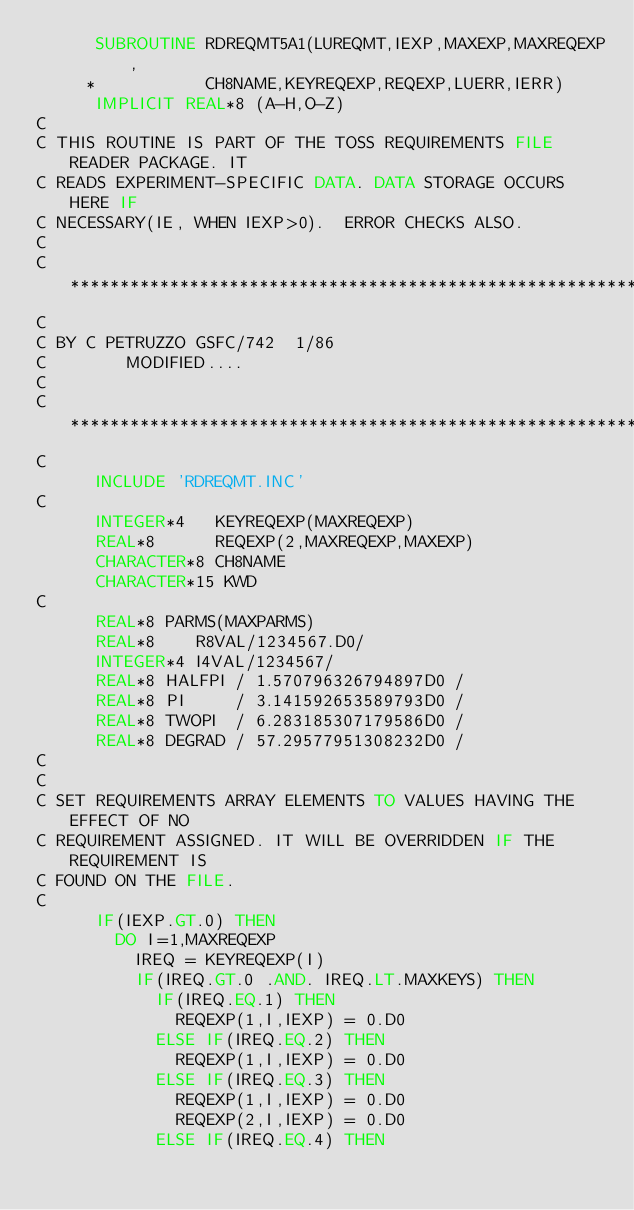Convert code to text. <code><loc_0><loc_0><loc_500><loc_500><_FORTRAN_>      SUBROUTINE RDREQMT5A1(LUREQMT,IEXP,MAXEXP,MAXREQEXP,
     *           CH8NAME,KEYREQEXP,REQEXP,LUERR,IERR)
      IMPLICIT REAL*8 (A-H,O-Z)
C
C THIS ROUTINE IS PART OF THE TOSS REQUIREMENTS FILE READER PACKAGE. IT
C READS EXPERIMENT-SPECIFIC DATA. DATA STORAGE OCCURS HERE IF
C NECESSARY(IE, WHEN IEXP>0).  ERROR CHECKS ALSO.
C
C***********************************************************************
C
C BY C PETRUZZO GSFC/742  1/86
C        MODIFIED....
C
C***********************************************************************
C
      INCLUDE 'RDREQMT.INC'
C
      INTEGER*4   KEYREQEXP(MAXREQEXP)
      REAL*8      REQEXP(2,MAXREQEXP,MAXEXP)
      CHARACTER*8 CH8NAME
      CHARACTER*15 KWD
C
      REAL*8 PARMS(MAXPARMS)
      REAL*8    R8VAL/1234567.D0/
      INTEGER*4 I4VAL/1234567/
      REAL*8 HALFPI / 1.570796326794897D0 /
      REAL*8 PI     / 3.141592653589793D0 /
      REAL*8 TWOPI  / 6.283185307179586D0 /
      REAL*8 DEGRAD / 57.29577951308232D0 /
C
C
C SET REQUIREMENTS ARRAY ELEMENTS TO VALUES HAVING THE EFFECT OF NO
C REQUIREMENT ASSIGNED. IT WILL BE OVERRIDDEN IF THE REQUIREMENT IS
C FOUND ON THE FILE.
C
      IF(IEXP.GT.0) THEN
        DO I=1,MAXREQEXP
          IREQ = KEYREQEXP(I)
          IF(IREQ.GT.0 .AND. IREQ.LT.MAXKEYS) THEN
            IF(IREQ.EQ.1) THEN
              REQEXP(1,I,IEXP) = 0.D0
            ELSE IF(IREQ.EQ.2) THEN
              REQEXP(1,I,IEXP) = 0.D0
            ELSE IF(IREQ.EQ.3) THEN
              REQEXP(1,I,IEXP) = 0.D0
              REQEXP(2,I,IEXP) = 0.D0
            ELSE IF(IREQ.EQ.4) THEN</code> 